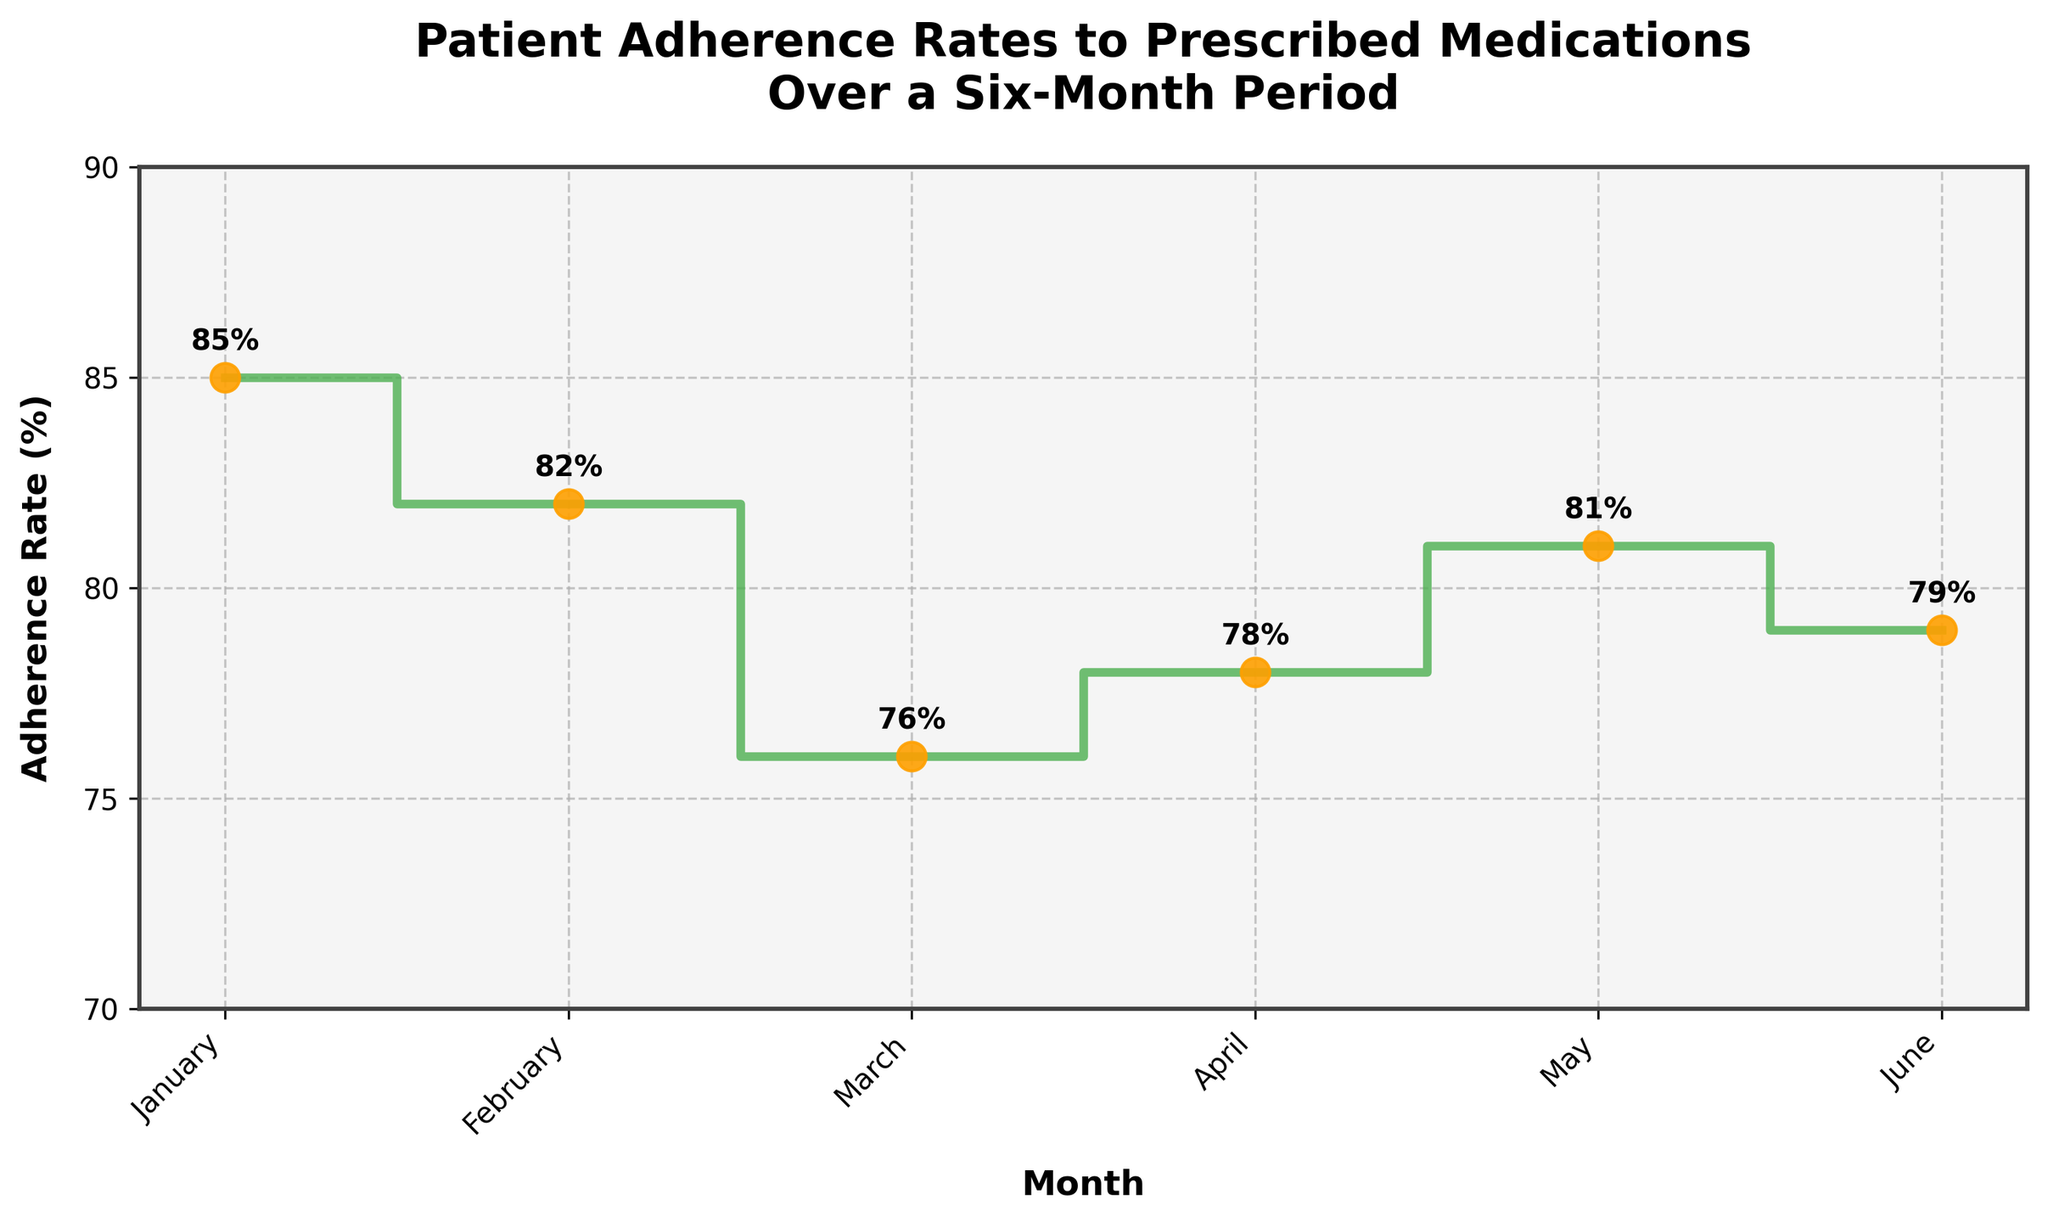What is the title of the plot? The title of the plot is printed at the top, which describes what the plot is about.
Answer: Patient Adherence Rates to Prescribed Medications Over a Six-Month Period What is the adherence rate in March? To find the adherence rate in March, locate the month on the horizontal axis and check the value on the vertical axis.
Answer: 76% Which month has the highest adherence rate? Compare all the adherence rates plotted for each month and identify the highest value. January has 85%, which is the highest among all the months.
Answer: January What is the average adherence rate over the six-month period? Sum up the adherence rates (85 + 82 + 76 + 78 + 81 + 79) and divide by the number of months (6). (85 + 82 + 76 + 78 + 81 + 79) = 481, and 481/6 = ~80.17
Answer: ~80.17% What are the differences in adherence rates between January and February? Subtract February's adherence rate from January's adherence rate. (85 - 82)
Answer: 3% Which month shows a rise in adherence compared to the previous month? Compare the adherence rates month by month to see where the value increases from the previous month. In April, the adherence rate increases from March (78% > 76%).
Answer: April How many adherence rates are higher than 80%? Count the number of months where the adherence rate is above 80%. January (85%), February (82%), and May (81%) meet this criterion.
Answer: 3 What is the lowest adherence rate and during which month does it occur? Scan the adherence rates and identify the lowest value. Then check the corresponding month. The lowest rate is 76% in March.
Answer: 76%, March How does the adherence rate in June compare to that of April? To answer this, compare the adherence rates in June and April. June has a rate of 79%, and April has 78%. June's adherence rate is higher than April’s.
Answer: Higher 